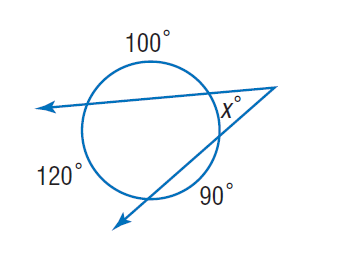Question: Find x.
Choices:
A. 35
B. 90
C. 100
D. 120
Answer with the letter. Answer: A 